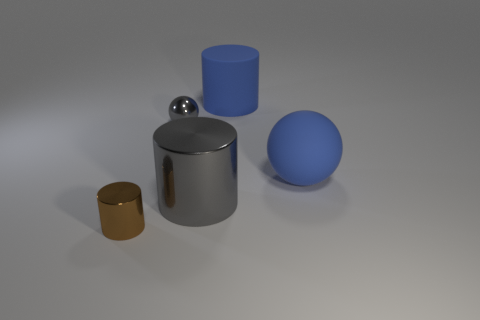Add 3 blue rubber cylinders. How many objects exist? 8 Subtract all balls. How many objects are left? 3 Subtract 0 purple spheres. How many objects are left? 5 Subtract all metallic balls. Subtract all small metal objects. How many objects are left? 2 Add 1 gray shiny balls. How many gray shiny balls are left? 2 Add 3 large yellow matte balls. How many large yellow matte balls exist? 3 